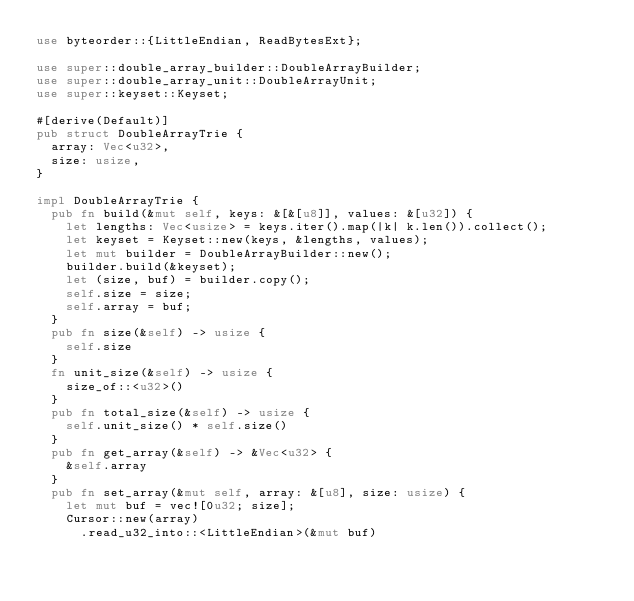Convert code to text. <code><loc_0><loc_0><loc_500><loc_500><_Rust_>use byteorder::{LittleEndian, ReadBytesExt};

use super::double_array_builder::DoubleArrayBuilder;
use super::double_array_unit::DoubleArrayUnit;
use super::keyset::Keyset;

#[derive(Default)]
pub struct DoubleArrayTrie {
  array: Vec<u32>,
  size: usize,
}

impl DoubleArrayTrie {
  pub fn build(&mut self, keys: &[&[u8]], values: &[u32]) {
    let lengths: Vec<usize> = keys.iter().map(|k| k.len()).collect();
    let keyset = Keyset::new(keys, &lengths, values);
    let mut builder = DoubleArrayBuilder::new();
    builder.build(&keyset);
    let (size, buf) = builder.copy();
    self.size = size;
    self.array = buf;
  }
  pub fn size(&self) -> usize {
    self.size
  }
  fn unit_size(&self) -> usize {
    size_of::<u32>()
  }
  pub fn total_size(&self) -> usize {
    self.unit_size() * self.size()
  }
  pub fn get_array(&self) -> &Vec<u32> {
    &self.array
  }
  pub fn set_array(&mut self, array: &[u8], size: usize) {
    let mut buf = vec![0u32; size];
    Cursor::new(array)
      .read_u32_into::<LittleEndian>(&mut buf)</code> 